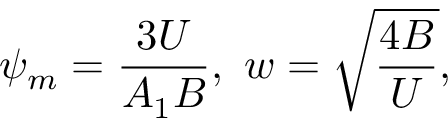Convert formula to latex. <formula><loc_0><loc_0><loc_500><loc_500>\psi _ { m } = \frac { 3 U } { A _ { 1 } B } , w = \sqrt { \frac { 4 B } { U } } ,</formula> 